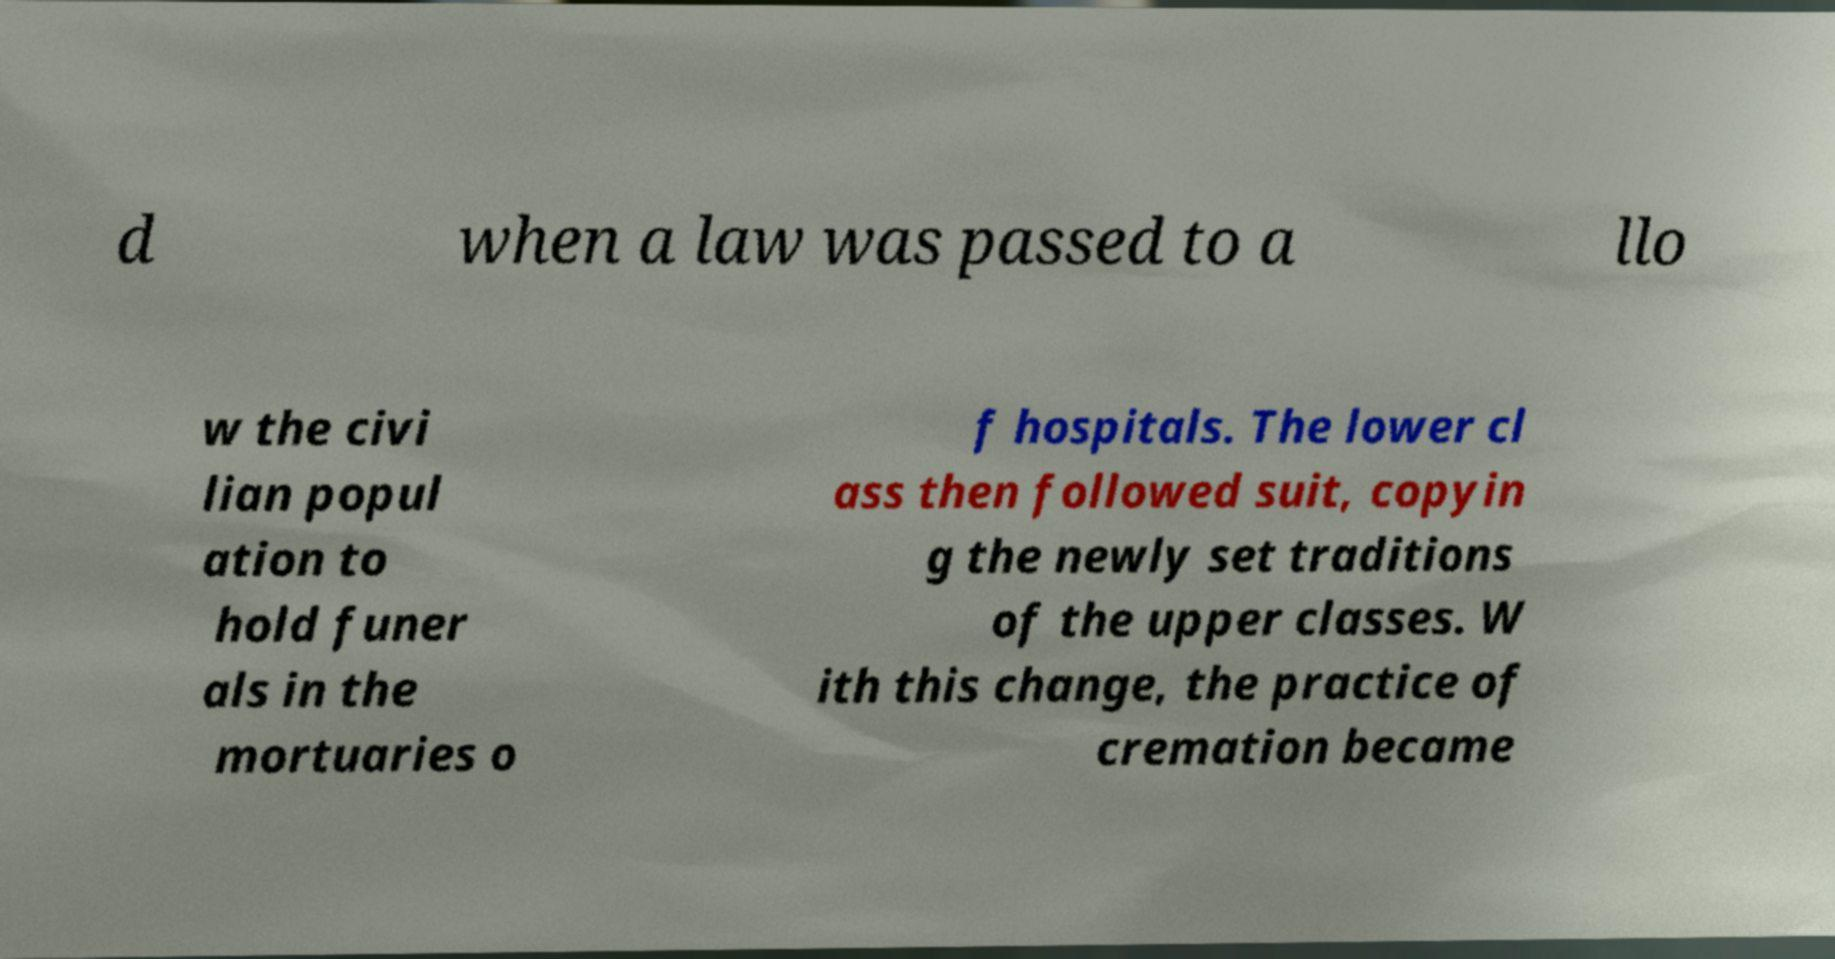Could you assist in decoding the text presented in this image and type it out clearly? d when a law was passed to a llo w the civi lian popul ation to hold funer als in the mortuaries o f hospitals. The lower cl ass then followed suit, copyin g the newly set traditions of the upper classes. W ith this change, the practice of cremation became 